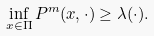Convert formula to latex. <formula><loc_0><loc_0><loc_500><loc_500>\inf _ { x \in \Pi } P ^ { m } ( x , \cdot ) \geq \lambda ( \cdot ) .</formula> 